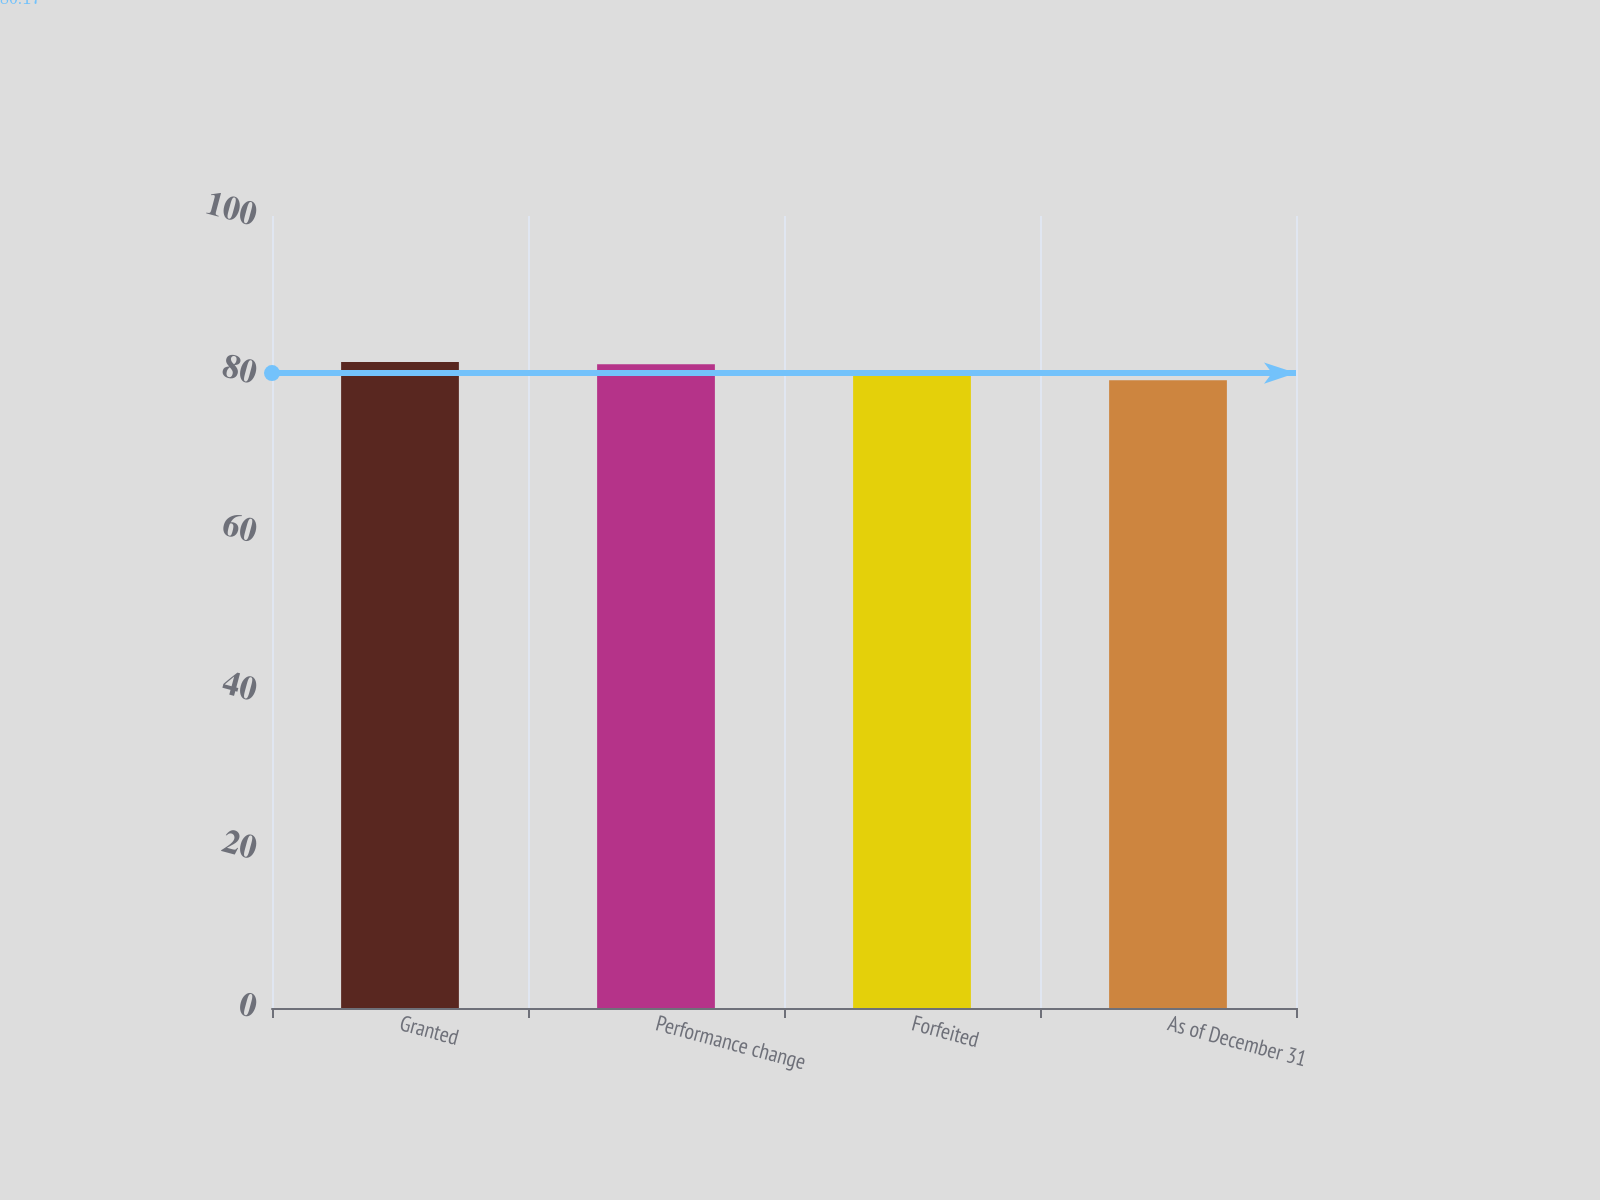Convert chart. <chart><loc_0><loc_0><loc_500><loc_500><bar_chart><fcel>Granted<fcel>Performance change<fcel>Forfeited<fcel>As of December 31<nl><fcel>81.55<fcel>81.27<fcel>80.21<fcel>79.27<nl></chart> 